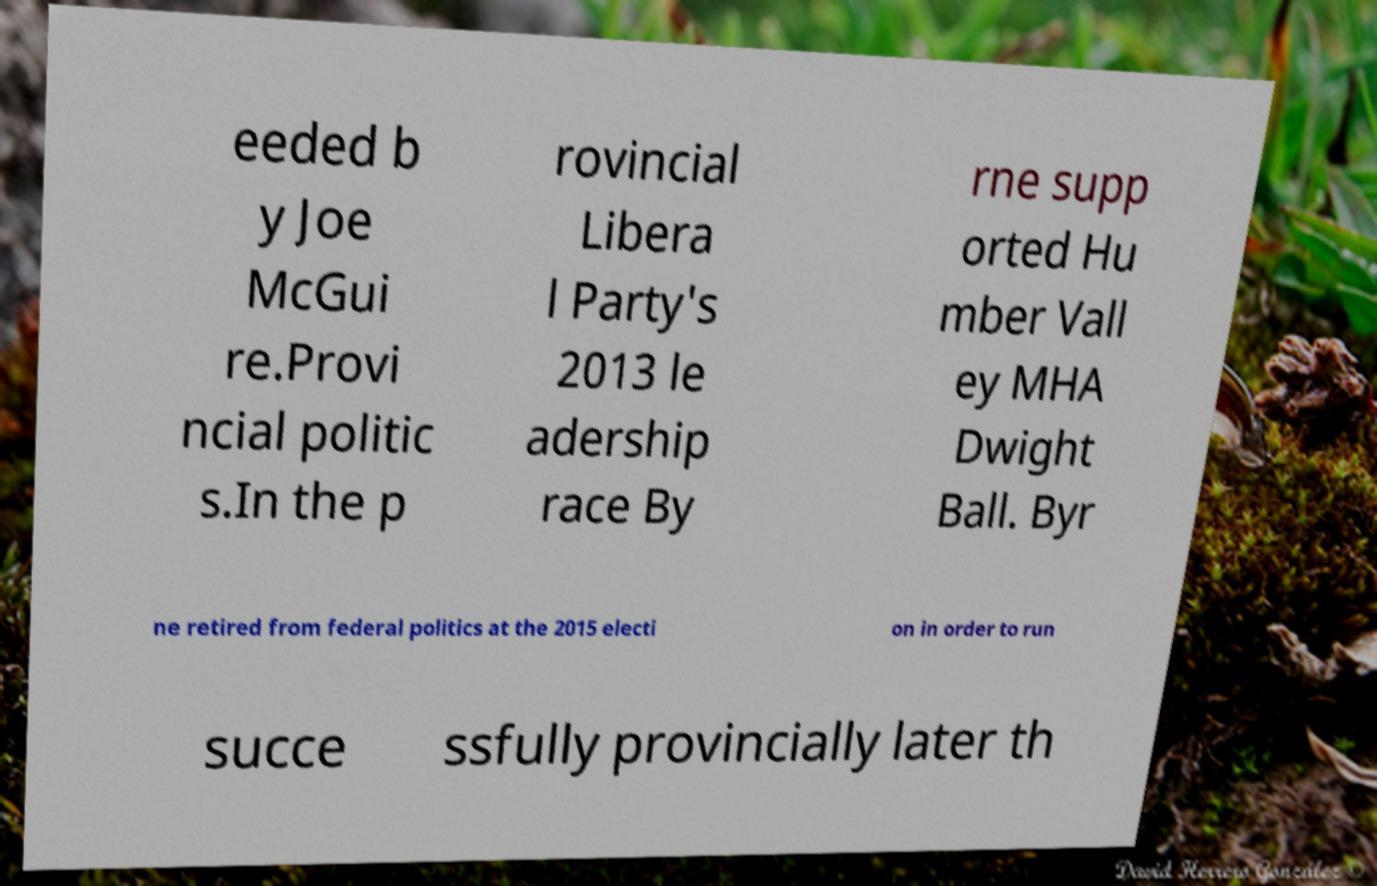There's text embedded in this image that I need extracted. Can you transcribe it verbatim? eeded b y Joe McGui re.Provi ncial politic s.In the p rovincial Libera l Party's 2013 le adership race By rne supp orted Hu mber Vall ey MHA Dwight Ball. Byr ne retired from federal politics at the 2015 electi on in order to run succe ssfully provincially later th 